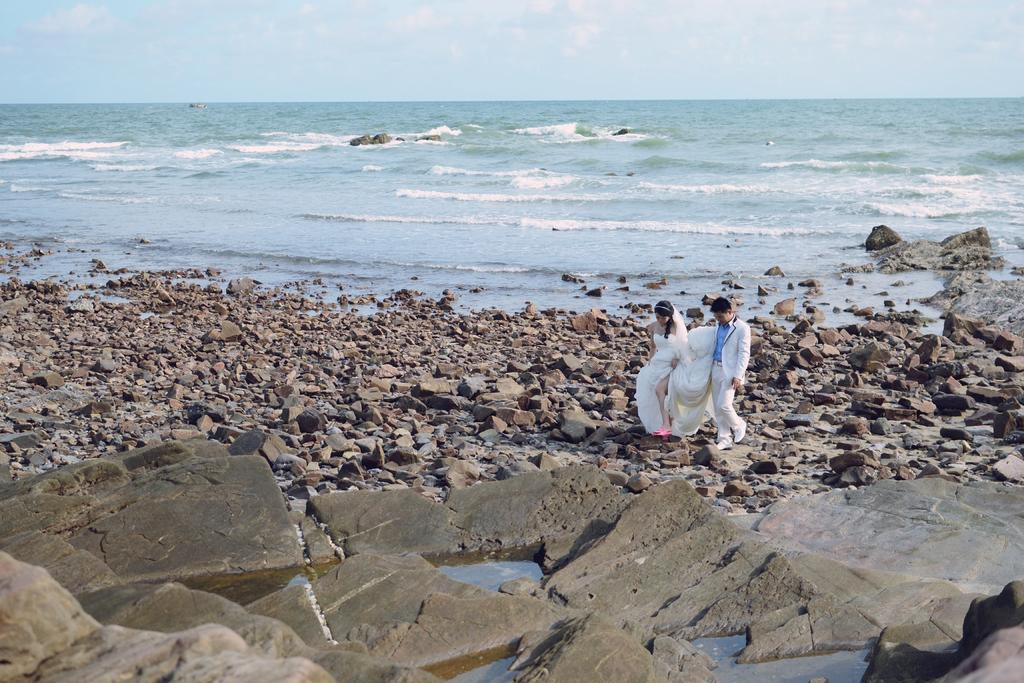How many people are in the image? There are two persons in the image. What are the persons doing in the image? The persons are standing on rocks. Can you describe the clothing of one of the persons? One man is wearing a white dress. What can be seen in the background of the image? There is a group of rocks, water, and the sky visible in the background of the image. What historical event is being commemorated by the persons in the image? There is no indication of a historical event being commemorated in the image. How does the water move around the rocks in the image? The water does not move around the rocks in the image; it is stationary and visible in the background. 